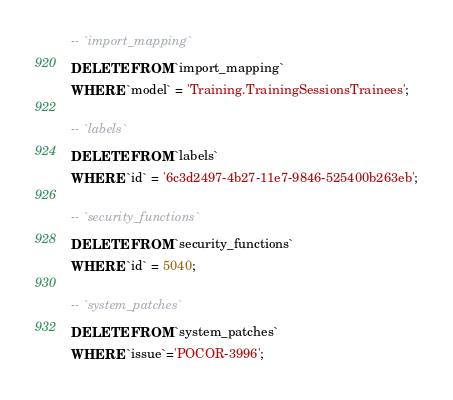Convert code to text. <code><loc_0><loc_0><loc_500><loc_500><_SQL_>-- `import_mapping`
DELETE FROM `import_mapping`
WHERE `model` = 'Training.TrainingSessionsTrainees';

-- `labels`
DELETE FROM `labels`
WHERE `id` = '6c3d2497-4b27-11e7-9846-525400b263eb';

-- `security_functions`
DELETE FROM `security_functions`
WHERE `id` = 5040;

-- `system_patches`
DELETE FROM `system_patches` 
WHERE `issue`='POCOR-3996';
</code> 